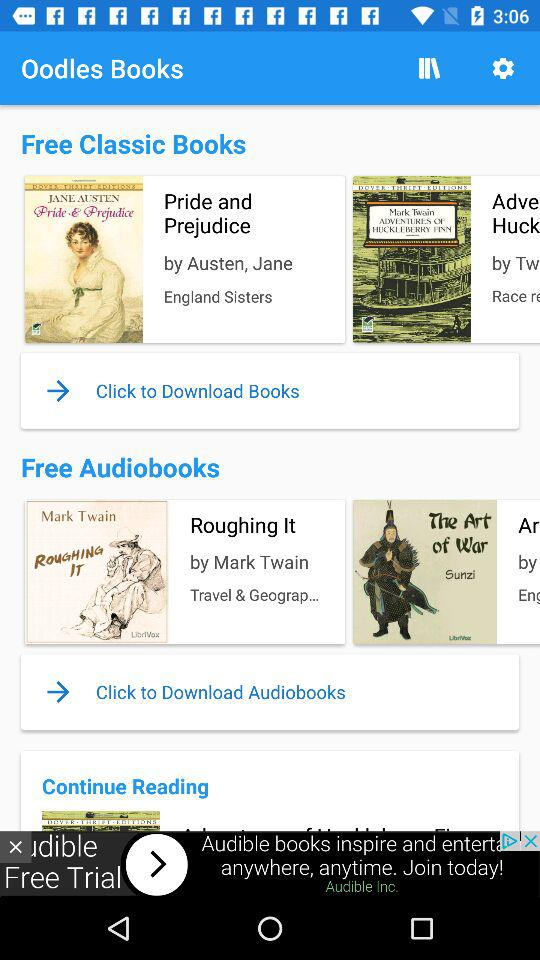Who is the author of the book "Roughing It"? The author is Mark Twain. 